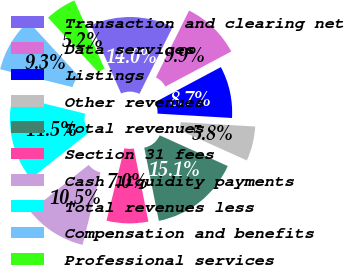Convert chart. <chart><loc_0><loc_0><loc_500><loc_500><pie_chart><fcel>Transaction and clearing net<fcel>Data services<fcel>Listings<fcel>Other revenues<fcel>Total revenues<fcel>Section 31 fees<fcel>Cash liquidity payments<fcel>Total revenues less<fcel>Compensation and benefits<fcel>Professional services<nl><fcel>13.95%<fcel>9.88%<fcel>8.72%<fcel>5.81%<fcel>15.12%<fcel>6.98%<fcel>10.47%<fcel>14.53%<fcel>9.3%<fcel>5.23%<nl></chart> 